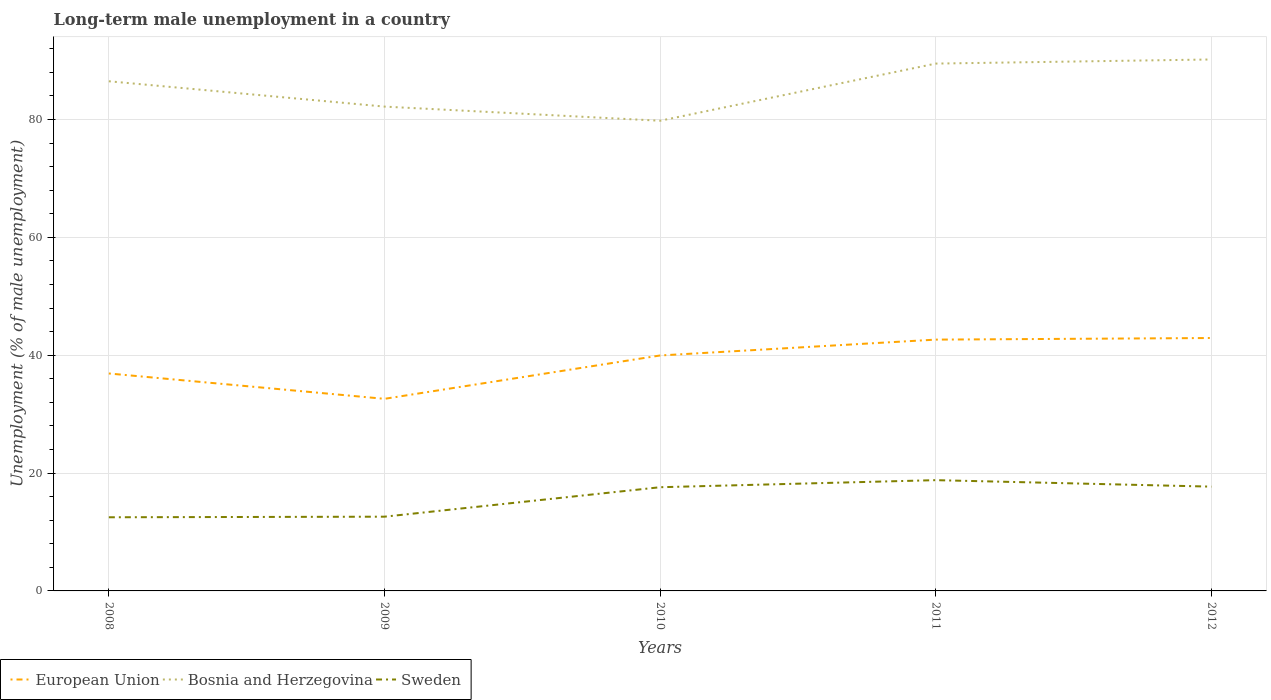Does the line corresponding to Bosnia and Herzegovina intersect with the line corresponding to European Union?
Offer a terse response. No. Is the number of lines equal to the number of legend labels?
Your answer should be compact. Yes. Across all years, what is the maximum percentage of long-term unemployed male population in European Union?
Offer a very short reply. 32.6. What is the total percentage of long-term unemployed male population in Sweden in the graph?
Keep it short and to the point. -6.3. What is the difference between the highest and the second highest percentage of long-term unemployed male population in Sweden?
Ensure brevity in your answer.  6.3. What is the difference between the highest and the lowest percentage of long-term unemployed male population in European Union?
Offer a terse response. 3. How many lines are there?
Offer a terse response. 3. Does the graph contain grids?
Give a very brief answer. Yes. Where does the legend appear in the graph?
Provide a succinct answer. Bottom left. How are the legend labels stacked?
Your answer should be compact. Horizontal. What is the title of the graph?
Your answer should be very brief. Long-term male unemployment in a country. Does "Djibouti" appear as one of the legend labels in the graph?
Your answer should be very brief. No. What is the label or title of the Y-axis?
Your answer should be compact. Unemployment (% of male unemployment). What is the Unemployment (% of male unemployment) of European Union in 2008?
Offer a very short reply. 36.91. What is the Unemployment (% of male unemployment) in Bosnia and Herzegovina in 2008?
Your response must be concise. 86.5. What is the Unemployment (% of male unemployment) in Sweden in 2008?
Your answer should be compact. 12.5. What is the Unemployment (% of male unemployment) in European Union in 2009?
Your response must be concise. 32.6. What is the Unemployment (% of male unemployment) in Bosnia and Herzegovina in 2009?
Your answer should be compact. 82.2. What is the Unemployment (% of male unemployment) in Sweden in 2009?
Your response must be concise. 12.6. What is the Unemployment (% of male unemployment) in European Union in 2010?
Provide a succinct answer. 39.96. What is the Unemployment (% of male unemployment) in Bosnia and Herzegovina in 2010?
Your answer should be very brief. 79.8. What is the Unemployment (% of male unemployment) in Sweden in 2010?
Offer a very short reply. 17.6. What is the Unemployment (% of male unemployment) of European Union in 2011?
Provide a short and direct response. 42.65. What is the Unemployment (% of male unemployment) in Bosnia and Herzegovina in 2011?
Give a very brief answer. 89.5. What is the Unemployment (% of male unemployment) of Sweden in 2011?
Provide a short and direct response. 18.8. What is the Unemployment (% of male unemployment) of European Union in 2012?
Keep it short and to the point. 42.92. What is the Unemployment (% of male unemployment) of Bosnia and Herzegovina in 2012?
Provide a succinct answer. 90.2. What is the Unemployment (% of male unemployment) in Sweden in 2012?
Your response must be concise. 17.7. Across all years, what is the maximum Unemployment (% of male unemployment) in European Union?
Ensure brevity in your answer.  42.92. Across all years, what is the maximum Unemployment (% of male unemployment) in Bosnia and Herzegovina?
Give a very brief answer. 90.2. Across all years, what is the maximum Unemployment (% of male unemployment) of Sweden?
Keep it short and to the point. 18.8. Across all years, what is the minimum Unemployment (% of male unemployment) of European Union?
Give a very brief answer. 32.6. Across all years, what is the minimum Unemployment (% of male unemployment) of Bosnia and Herzegovina?
Your answer should be very brief. 79.8. What is the total Unemployment (% of male unemployment) in European Union in the graph?
Keep it short and to the point. 195.05. What is the total Unemployment (% of male unemployment) of Bosnia and Herzegovina in the graph?
Offer a terse response. 428.2. What is the total Unemployment (% of male unemployment) in Sweden in the graph?
Your answer should be compact. 79.2. What is the difference between the Unemployment (% of male unemployment) in European Union in 2008 and that in 2009?
Your answer should be compact. 4.3. What is the difference between the Unemployment (% of male unemployment) in Bosnia and Herzegovina in 2008 and that in 2009?
Your answer should be very brief. 4.3. What is the difference between the Unemployment (% of male unemployment) of European Union in 2008 and that in 2010?
Offer a terse response. -3.06. What is the difference between the Unemployment (% of male unemployment) in Sweden in 2008 and that in 2010?
Offer a terse response. -5.1. What is the difference between the Unemployment (% of male unemployment) in European Union in 2008 and that in 2011?
Offer a very short reply. -5.75. What is the difference between the Unemployment (% of male unemployment) of Sweden in 2008 and that in 2011?
Provide a succinct answer. -6.3. What is the difference between the Unemployment (% of male unemployment) in European Union in 2008 and that in 2012?
Provide a short and direct response. -6.02. What is the difference between the Unemployment (% of male unemployment) in Sweden in 2008 and that in 2012?
Keep it short and to the point. -5.2. What is the difference between the Unemployment (% of male unemployment) in European Union in 2009 and that in 2010?
Make the answer very short. -7.36. What is the difference between the Unemployment (% of male unemployment) of European Union in 2009 and that in 2011?
Keep it short and to the point. -10.05. What is the difference between the Unemployment (% of male unemployment) in European Union in 2009 and that in 2012?
Provide a succinct answer. -10.32. What is the difference between the Unemployment (% of male unemployment) in Bosnia and Herzegovina in 2009 and that in 2012?
Give a very brief answer. -8. What is the difference between the Unemployment (% of male unemployment) in European Union in 2010 and that in 2011?
Make the answer very short. -2.69. What is the difference between the Unemployment (% of male unemployment) of Bosnia and Herzegovina in 2010 and that in 2011?
Your answer should be compact. -9.7. What is the difference between the Unemployment (% of male unemployment) of Sweden in 2010 and that in 2011?
Keep it short and to the point. -1.2. What is the difference between the Unemployment (% of male unemployment) in European Union in 2010 and that in 2012?
Provide a succinct answer. -2.96. What is the difference between the Unemployment (% of male unemployment) in Bosnia and Herzegovina in 2010 and that in 2012?
Offer a very short reply. -10.4. What is the difference between the Unemployment (% of male unemployment) in European Union in 2011 and that in 2012?
Provide a short and direct response. -0.27. What is the difference between the Unemployment (% of male unemployment) in Bosnia and Herzegovina in 2011 and that in 2012?
Your response must be concise. -0.7. What is the difference between the Unemployment (% of male unemployment) of European Union in 2008 and the Unemployment (% of male unemployment) of Bosnia and Herzegovina in 2009?
Offer a terse response. -45.29. What is the difference between the Unemployment (% of male unemployment) of European Union in 2008 and the Unemployment (% of male unemployment) of Sweden in 2009?
Provide a succinct answer. 24.31. What is the difference between the Unemployment (% of male unemployment) of Bosnia and Herzegovina in 2008 and the Unemployment (% of male unemployment) of Sweden in 2009?
Offer a very short reply. 73.9. What is the difference between the Unemployment (% of male unemployment) of European Union in 2008 and the Unemployment (% of male unemployment) of Bosnia and Herzegovina in 2010?
Your response must be concise. -42.89. What is the difference between the Unemployment (% of male unemployment) in European Union in 2008 and the Unemployment (% of male unemployment) in Sweden in 2010?
Ensure brevity in your answer.  19.31. What is the difference between the Unemployment (% of male unemployment) in Bosnia and Herzegovina in 2008 and the Unemployment (% of male unemployment) in Sweden in 2010?
Your answer should be compact. 68.9. What is the difference between the Unemployment (% of male unemployment) in European Union in 2008 and the Unemployment (% of male unemployment) in Bosnia and Herzegovina in 2011?
Make the answer very short. -52.59. What is the difference between the Unemployment (% of male unemployment) of European Union in 2008 and the Unemployment (% of male unemployment) of Sweden in 2011?
Your response must be concise. 18.11. What is the difference between the Unemployment (% of male unemployment) of Bosnia and Herzegovina in 2008 and the Unemployment (% of male unemployment) of Sweden in 2011?
Give a very brief answer. 67.7. What is the difference between the Unemployment (% of male unemployment) in European Union in 2008 and the Unemployment (% of male unemployment) in Bosnia and Herzegovina in 2012?
Offer a very short reply. -53.29. What is the difference between the Unemployment (% of male unemployment) in European Union in 2008 and the Unemployment (% of male unemployment) in Sweden in 2012?
Give a very brief answer. 19.21. What is the difference between the Unemployment (% of male unemployment) in Bosnia and Herzegovina in 2008 and the Unemployment (% of male unemployment) in Sweden in 2012?
Your answer should be compact. 68.8. What is the difference between the Unemployment (% of male unemployment) in European Union in 2009 and the Unemployment (% of male unemployment) in Bosnia and Herzegovina in 2010?
Your response must be concise. -47.2. What is the difference between the Unemployment (% of male unemployment) of European Union in 2009 and the Unemployment (% of male unemployment) of Sweden in 2010?
Your response must be concise. 15. What is the difference between the Unemployment (% of male unemployment) in Bosnia and Herzegovina in 2009 and the Unemployment (% of male unemployment) in Sweden in 2010?
Provide a short and direct response. 64.6. What is the difference between the Unemployment (% of male unemployment) in European Union in 2009 and the Unemployment (% of male unemployment) in Bosnia and Herzegovina in 2011?
Provide a succinct answer. -56.9. What is the difference between the Unemployment (% of male unemployment) of European Union in 2009 and the Unemployment (% of male unemployment) of Sweden in 2011?
Ensure brevity in your answer.  13.8. What is the difference between the Unemployment (% of male unemployment) of Bosnia and Herzegovina in 2009 and the Unemployment (% of male unemployment) of Sweden in 2011?
Make the answer very short. 63.4. What is the difference between the Unemployment (% of male unemployment) in European Union in 2009 and the Unemployment (% of male unemployment) in Bosnia and Herzegovina in 2012?
Your answer should be very brief. -57.6. What is the difference between the Unemployment (% of male unemployment) of European Union in 2009 and the Unemployment (% of male unemployment) of Sweden in 2012?
Offer a terse response. 14.9. What is the difference between the Unemployment (% of male unemployment) of Bosnia and Herzegovina in 2009 and the Unemployment (% of male unemployment) of Sweden in 2012?
Make the answer very short. 64.5. What is the difference between the Unemployment (% of male unemployment) of European Union in 2010 and the Unemployment (% of male unemployment) of Bosnia and Herzegovina in 2011?
Your answer should be very brief. -49.54. What is the difference between the Unemployment (% of male unemployment) in European Union in 2010 and the Unemployment (% of male unemployment) in Sweden in 2011?
Provide a short and direct response. 21.16. What is the difference between the Unemployment (% of male unemployment) in European Union in 2010 and the Unemployment (% of male unemployment) in Bosnia and Herzegovina in 2012?
Keep it short and to the point. -50.24. What is the difference between the Unemployment (% of male unemployment) of European Union in 2010 and the Unemployment (% of male unemployment) of Sweden in 2012?
Offer a terse response. 22.26. What is the difference between the Unemployment (% of male unemployment) of Bosnia and Herzegovina in 2010 and the Unemployment (% of male unemployment) of Sweden in 2012?
Your response must be concise. 62.1. What is the difference between the Unemployment (% of male unemployment) of European Union in 2011 and the Unemployment (% of male unemployment) of Bosnia and Herzegovina in 2012?
Offer a very short reply. -47.55. What is the difference between the Unemployment (% of male unemployment) in European Union in 2011 and the Unemployment (% of male unemployment) in Sweden in 2012?
Provide a short and direct response. 24.95. What is the difference between the Unemployment (% of male unemployment) of Bosnia and Herzegovina in 2011 and the Unemployment (% of male unemployment) of Sweden in 2012?
Your response must be concise. 71.8. What is the average Unemployment (% of male unemployment) of European Union per year?
Your response must be concise. 39.01. What is the average Unemployment (% of male unemployment) in Bosnia and Herzegovina per year?
Your answer should be compact. 85.64. What is the average Unemployment (% of male unemployment) of Sweden per year?
Provide a short and direct response. 15.84. In the year 2008, what is the difference between the Unemployment (% of male unemployment) in European Union and Unemployment (% of male unemployment) in Bosnia and Herzegovina?
Provide a short and direct response. -49.59. In the year 2008, what is the difference between the Unemployment (% of male unemployment) of European Union and Unemployment (% of male unemployment) of Sweden?
Offer a terse response. 24.41. In the year 2008, what is the difference between the Unemployment (% of male unemployment) of Bosnia and Herzegovina and Unemployment (% of male unemployment) of Sweden?
Your response must be concise. 74. In the year 2009, what is the difference between the Unemployment (% of male unemployment) in European Union and Unemployment (% of male unemployment) in Bosnia and Herzegovina?
Your answer should be compact. -49.6. In the year 2009, what is the difference between the Unemployment (% of male unemployment) of European Union and Unemployment (% of male unemployment) of Sweden?
Ensure brevity in your answer.  20. In the year 2009, what is the difference between the Unemployment (% of male unemployment) of Bosnia and Herzegovina and Unemployment (% of male unemployment) of Sweden?
Give a very brief answer. 69.6. In the year 2010, what is the difference between the Unemployment (% of male unemployment) of European Union and Unemployment (% of male unemployment) of Bosnia and Herzegovina?
Keep it short and to the point. -39.84. In the year 2010, what is the difference between the Unemployment (% of male unemployment) in European Union and Unemployment (% of male unemployment) in Sweden?
Ensure brevity in your answer.  22.36. In the year 2010, what is the difference between the Unemployment (% of male unemployment) in Bosnia and Herzegovina and Unemployment (% of male unemployment) in Sweden?
Provide a short and direct response. 62.2. In the year 2011, what is the difference between the Unemployment (% of male unemployment) of European Union and Unemployment (% of male unemployment) of Bosnia and Herzegovina?
Give a very brief answer. -46.85. In the year 2011, what is the difference between the Unemployment (% of male unemployment) in European Union and Unemployment (% of male unemployment) in Sweden?
Your answer should be compact. 23.85. In the year 2011, what is the difference between the Unemployment (% of male unemployment) in Bosnia and Herzegovina and Unemployment (% of male unemployment) in Sweden?
Your response must be concise. 70.7. In the year 2012, what is the difference between the Unemployment (% of male unemployment) of European Union and Unemployment (% of male unemployment) of Bosnia and Herzegovina?
Ensure brevity in your answer.  -47.28. In the year 2012, what is the difference between the Unemployment (% of male unemployment) in European Union and Unemployment (% of male unemployment) in Sweden?
Provide a short and direct response. 25.22. In the year 2012, what is the difference between the Unemployment (% of male unemployment) in Bosnia and Herzegovina and Unemployment (% of male unemployment) in Sweden?
Give a very brief answer. 72.5. What is the ratio of the Unemployment (% of male unemployment) in European Union in 2008 to that in 2009?
Offer a terse response. 1.13. What is the ratio of the Unemployment (% of male unemployment) of Bosnia and Herzegovina in 2008 to that in 2009?
Give a very brief answer. 1.05. What is the ratio of the Unemployment (% of male unemployment) in Sweden in 2008 to that in 2009?
Offer a very short reply. 0.99. What is the ratio of the Unemployment (% of male unemployment) in European Union in 2008 to that in 2010?
Keep it short and to the point. 0.92. What is the ratio of the Unemployment (% of male unemployment) of Bosnia and Herzegovina in 2008 to that in 2010?
Offer a very short reply. 1.08. What is the ratio of the Unemployment (% of male unemployment) in Sweden in 2008 to that in 2010?
Offer a terse response. 0.71. What is the ratio of the Unemployment (% of male unemployment) in European Union in 2008 to that in 2011?
Offer a very short reply. 0.87. What is the ratio of the Unemployment (% of male unemployment) in Bosnia and Herzegovina in 2008 to that in 2011?
Keep it short and to the point. 0.97. What is the ratio of the Unemployment (% of male unemployment) of Sweden in 2008 to that in 2011?
Provide a succinct answer. 0.66. What is the ratio of the Unemployment (% of male unemployment) in European Union in 2008 to that in 2012?
Offer a very short reply. 0.86. What is the ratio of the Unemployment (% of male unemployment) of Sweden in 2008 to that in 2012?
Your answer should be compact. 0.71. What is the ratio of the Unemployment (% of male unemployment) in European Union in 2009 to that in 2010?
Your answer should be compact. 0.82. What is the ratio of the Unemployment (% of male unemployment) in Bosnia and Herzegovina in 2009 to that in 2010?
Offer a very short reply. 1.03. What is the ratio of the Unemployment (% of male unemployment) in Sweden in 2009 to that in 2010?
Give a very brief answer. 0.72. What is the ratio of the Unemployment (% of male unemployment) of European Union in 2009 to that in 2011?
Make the answer very short. 0.76. What is the ratio of the Unemployment (% of male unemployment) in Bosnia and Herzegovina in 2009 to that in 2011?
Your answer should be compact. 0.92. What is the ratio of the Unemployment (% of male unemployment) in Sweden in 2009 to that in 2011?
Your answer should be very brief. 0.67. What is the ratio of the Unemployment (% of male unemployment) in European Union in 2009 to that in 2012?
Make the answer very short. 0.76. What is the ratio of the Unemployment (% of male unemployment) in Bosnia and Herzegovina in 2009 to that in 2012?
Make the answer very short. 0.91. What is the ratio of the Unemployment (% of male unemployment) of Sweden in 2009 to that in 2012?
Make the answer very short. 0.71. What is the ratio of the Unemployment (% of male unemployment) in European Union in 2010 to that in 2011?
Offer a very short reply. 0.94. What is the ratio of the Unemployment (% of male unemployment) in Bosnia and Herzegovina in 2010 to that in 2011?
Give a very brief answer. 0.89. What is the ratio of the Unemployment (% of male unemployment) in Sweden in 2010 to that in 2011?
Your answer should be compact. 0.94. What is the ratio of the Unemployment (% of male unemployment) in European Union in 2010 to that in 2012?
Offer a very short reply. 0.93. What is the ratio of the Unemployment (% of male unemployment) of Bosnia and Herzegovina in 2010 to that in 2012?
Provide a succinct answer. 0.88. What is the ratio of the Unemployment (% of male unemployment) in Sweden in 2010 to that in 2012?
Ensure brevity in your answer.  0.99. What is the ratio of the Unemployment (% of male unemployment) in European Union in 2011 to that in 2012?
Offer a terse response. 0.99. What is the ratio of the Unemployment (% of male unemployment) of Bosnia and Herzegovina in 2011 to that in 2012?
Provide a succinct answer. 0.99. What is the ratio of the Unemployment (% of male unemployment) in Sweden in 2011 to that in 2012?
Ensure brevity in your answer.  1.06. What is the difference between the highest and the second highest Unemployment (% of male unemployment) of European Union?
Make the answer very short. 0.27. What is the difference between the highest and the second highest Unemployment (% of male unemployment) in Bosnia and Herzegovina?
Keep it short and to the point. 0.7. What is the difference between the highest and the second highest Unemployment (% of male unemployment) in Sweden?
Offer a very short reply. 1.1. What is the difference between the highest and the lowest Unemployment (% of male unemployment) of European Union?
Provide a succinct answer. 10.32. What is the difference between the highest and the lowest Unemployment (% of male unemployment) in Sweden?
Provide a succinct answer. 6.3. 